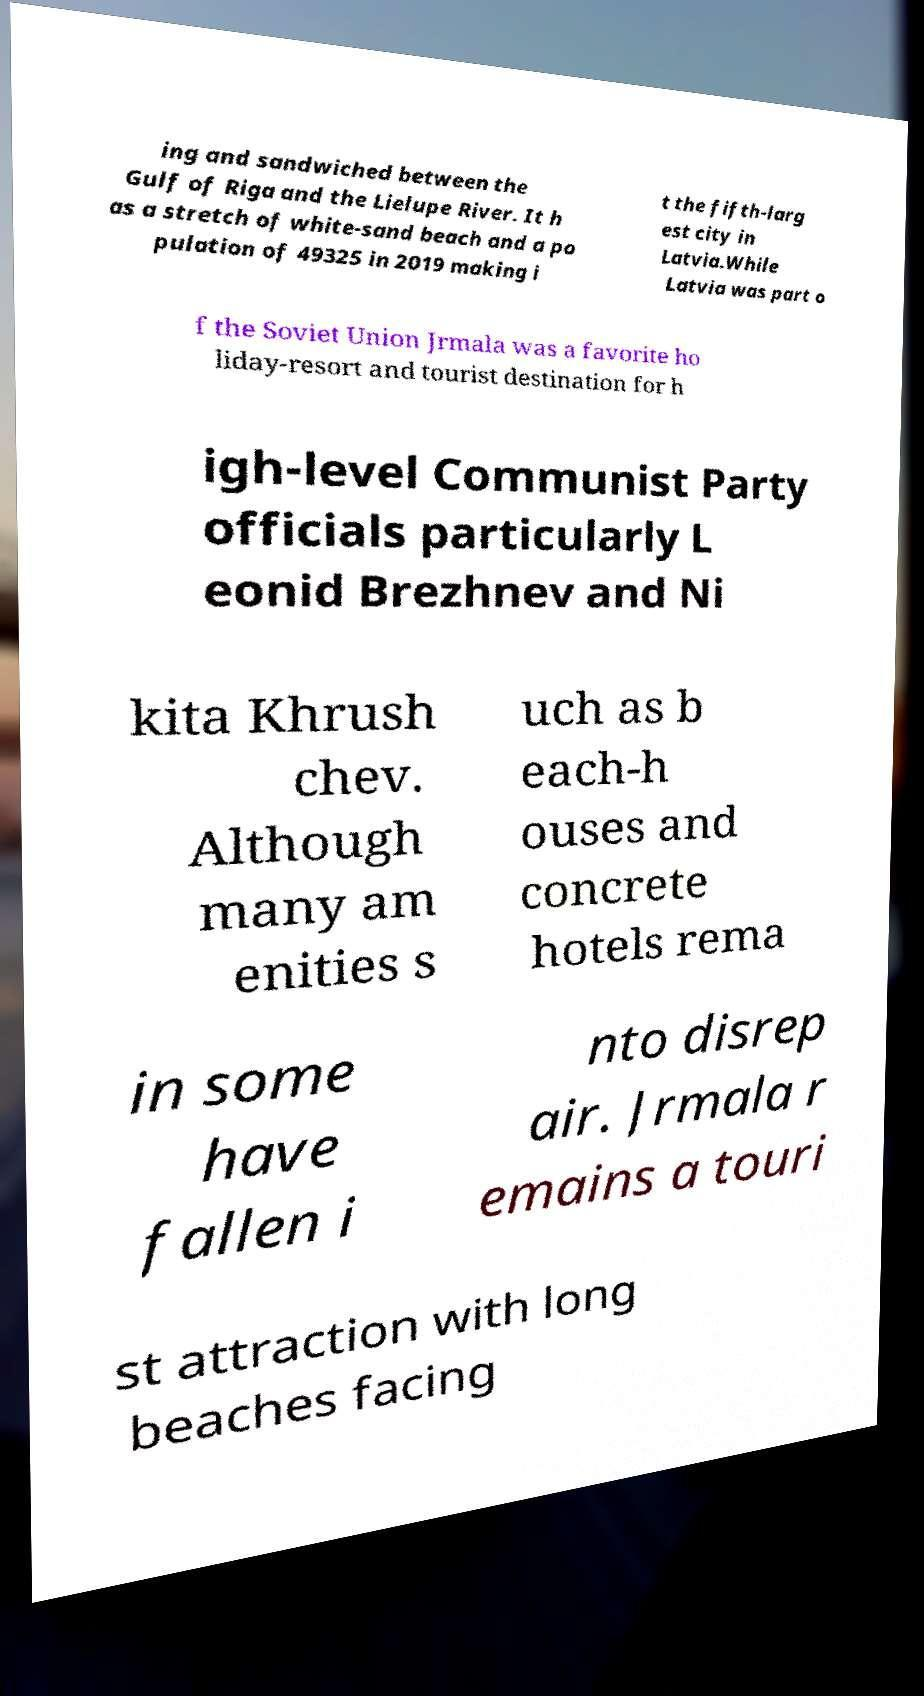Could you extract and type out the text from this image? ing and sandwiched between the Gulf of Riga and the Lielupe River. It h as a stretch of white-sand beach and a po pulation of 49325 in 2019 making i t the fifth-larg est city in Latvia.While Latvia was part o f the Soviet Union Jrmala was a favorite ho liday-resort and tourist destination for h igh-level Communist Party officials particularly L eonid Brezhnev and Ni kita Khrush chev. Although many am enities s uch as b each-h ouses and concrete hotels rema in some have fallen i nto disrep air. Jrmala r emains a touri st attraction with long beaches facing 